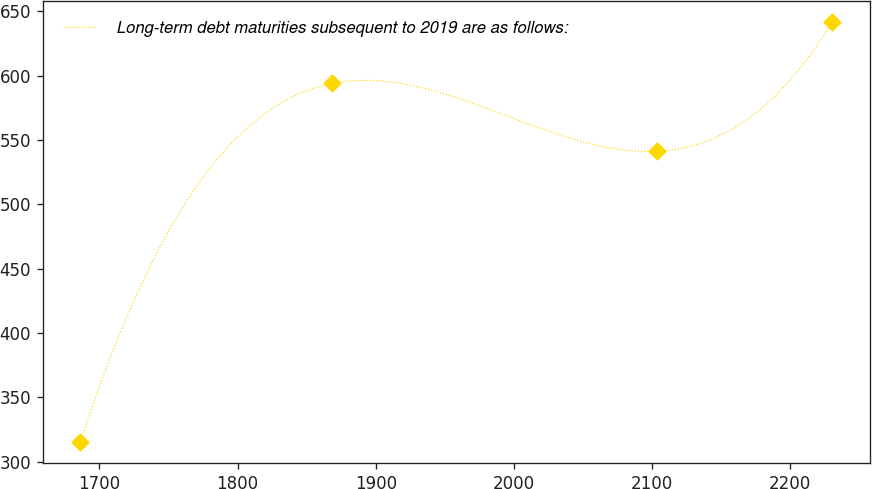<chart> <loc_0><loc_0><loc_500><loc_500><line_chart><ecel><fcel>Long-term debt maturities subsequent to 2019 are as follows:<nl><fcel>1686.12<fcel>315.02<nl><fcel>1868.59<fcel>593.94<nl><fcel>2103.45<fcel>541.24<nl><fcel>2230.46<fcel>641.49<nl></chart> 